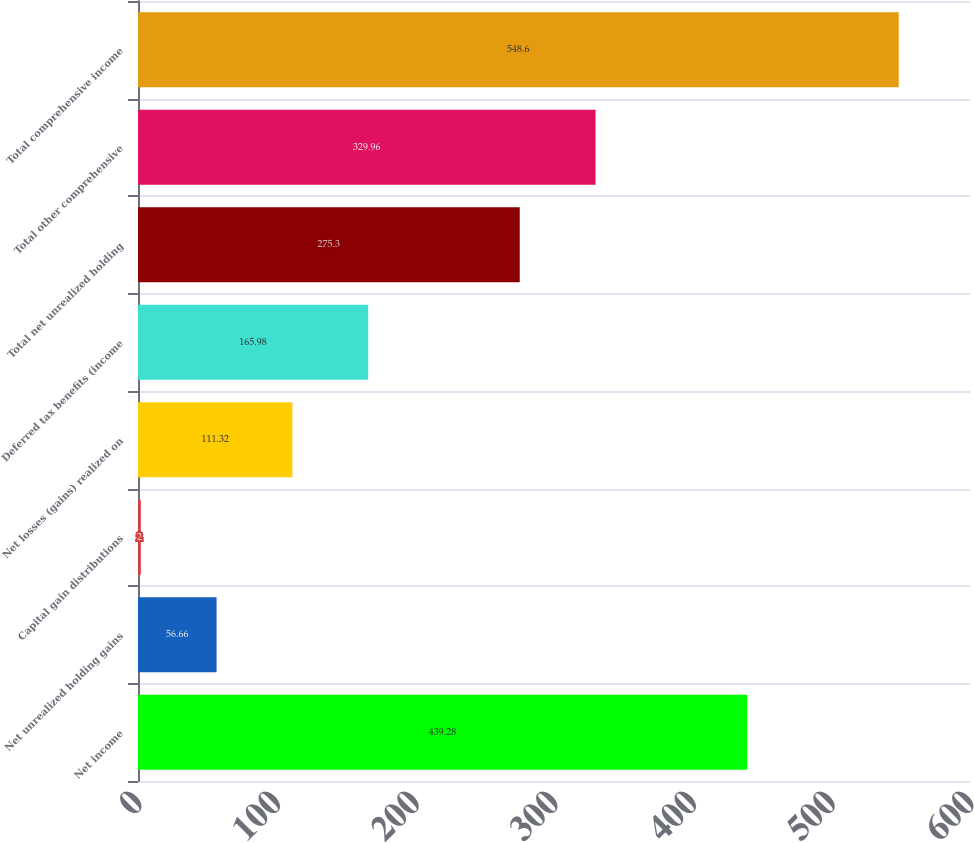<chart> <loc_0><loc_0><loc_500><loc_500><bar_chart><fcel>Net income<fcel>Net unrealized holding gains<fcel>Capital gain distributions<fcel>Net losses (gains) realized on<fcel>Deferred tax benefits (income<fcel>Total net unrealized holding<fcel>Total other comprehensive<fcel>Total comprehensive income<nl><fcel>439.28<fcel>56.66<fcel>2<fcel>111.32<fcel>165.98<fcel>275.3<fcel>329.96<fcel>548.6<nl></chart> 